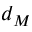Convert formula to latex. <formula><loc_0><loc_0><loc_500><loc_500>d _ { M }</formula> 